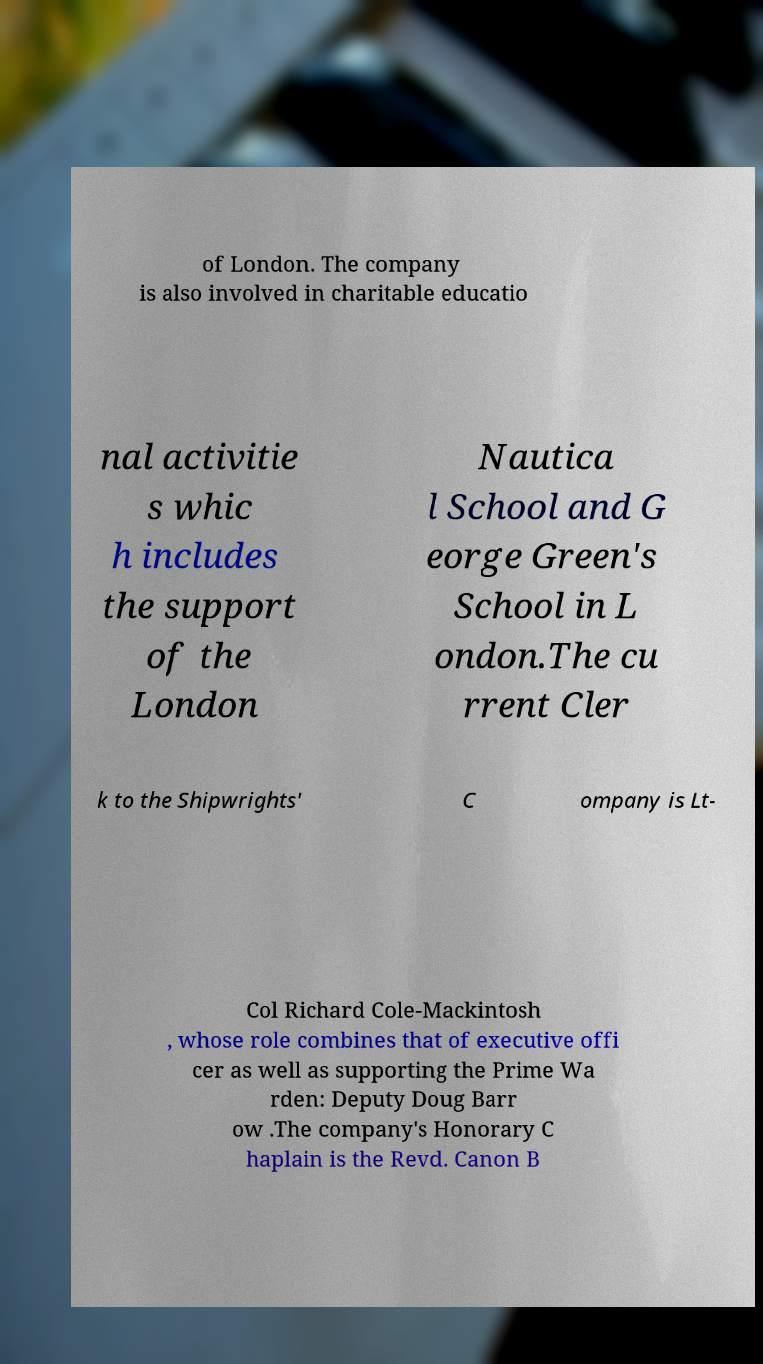Could you assist in decoding the text presented in this image and type it out clearly? of London. The company is also involved in charitable educatio nal activitie s whic h includes the support of the London Nautica l School and G eorge Green's School in L ondon.The cu rrent Cler k to the Shipwrights' C ompany is Lt- Col Richard Cole-Mackintosh , whose role combines that of executive offi cer as well as supporting the Prime Wa rden: Deputy Doug Barr ow .The company's Honorary C haplain is the Revd. Canon B 